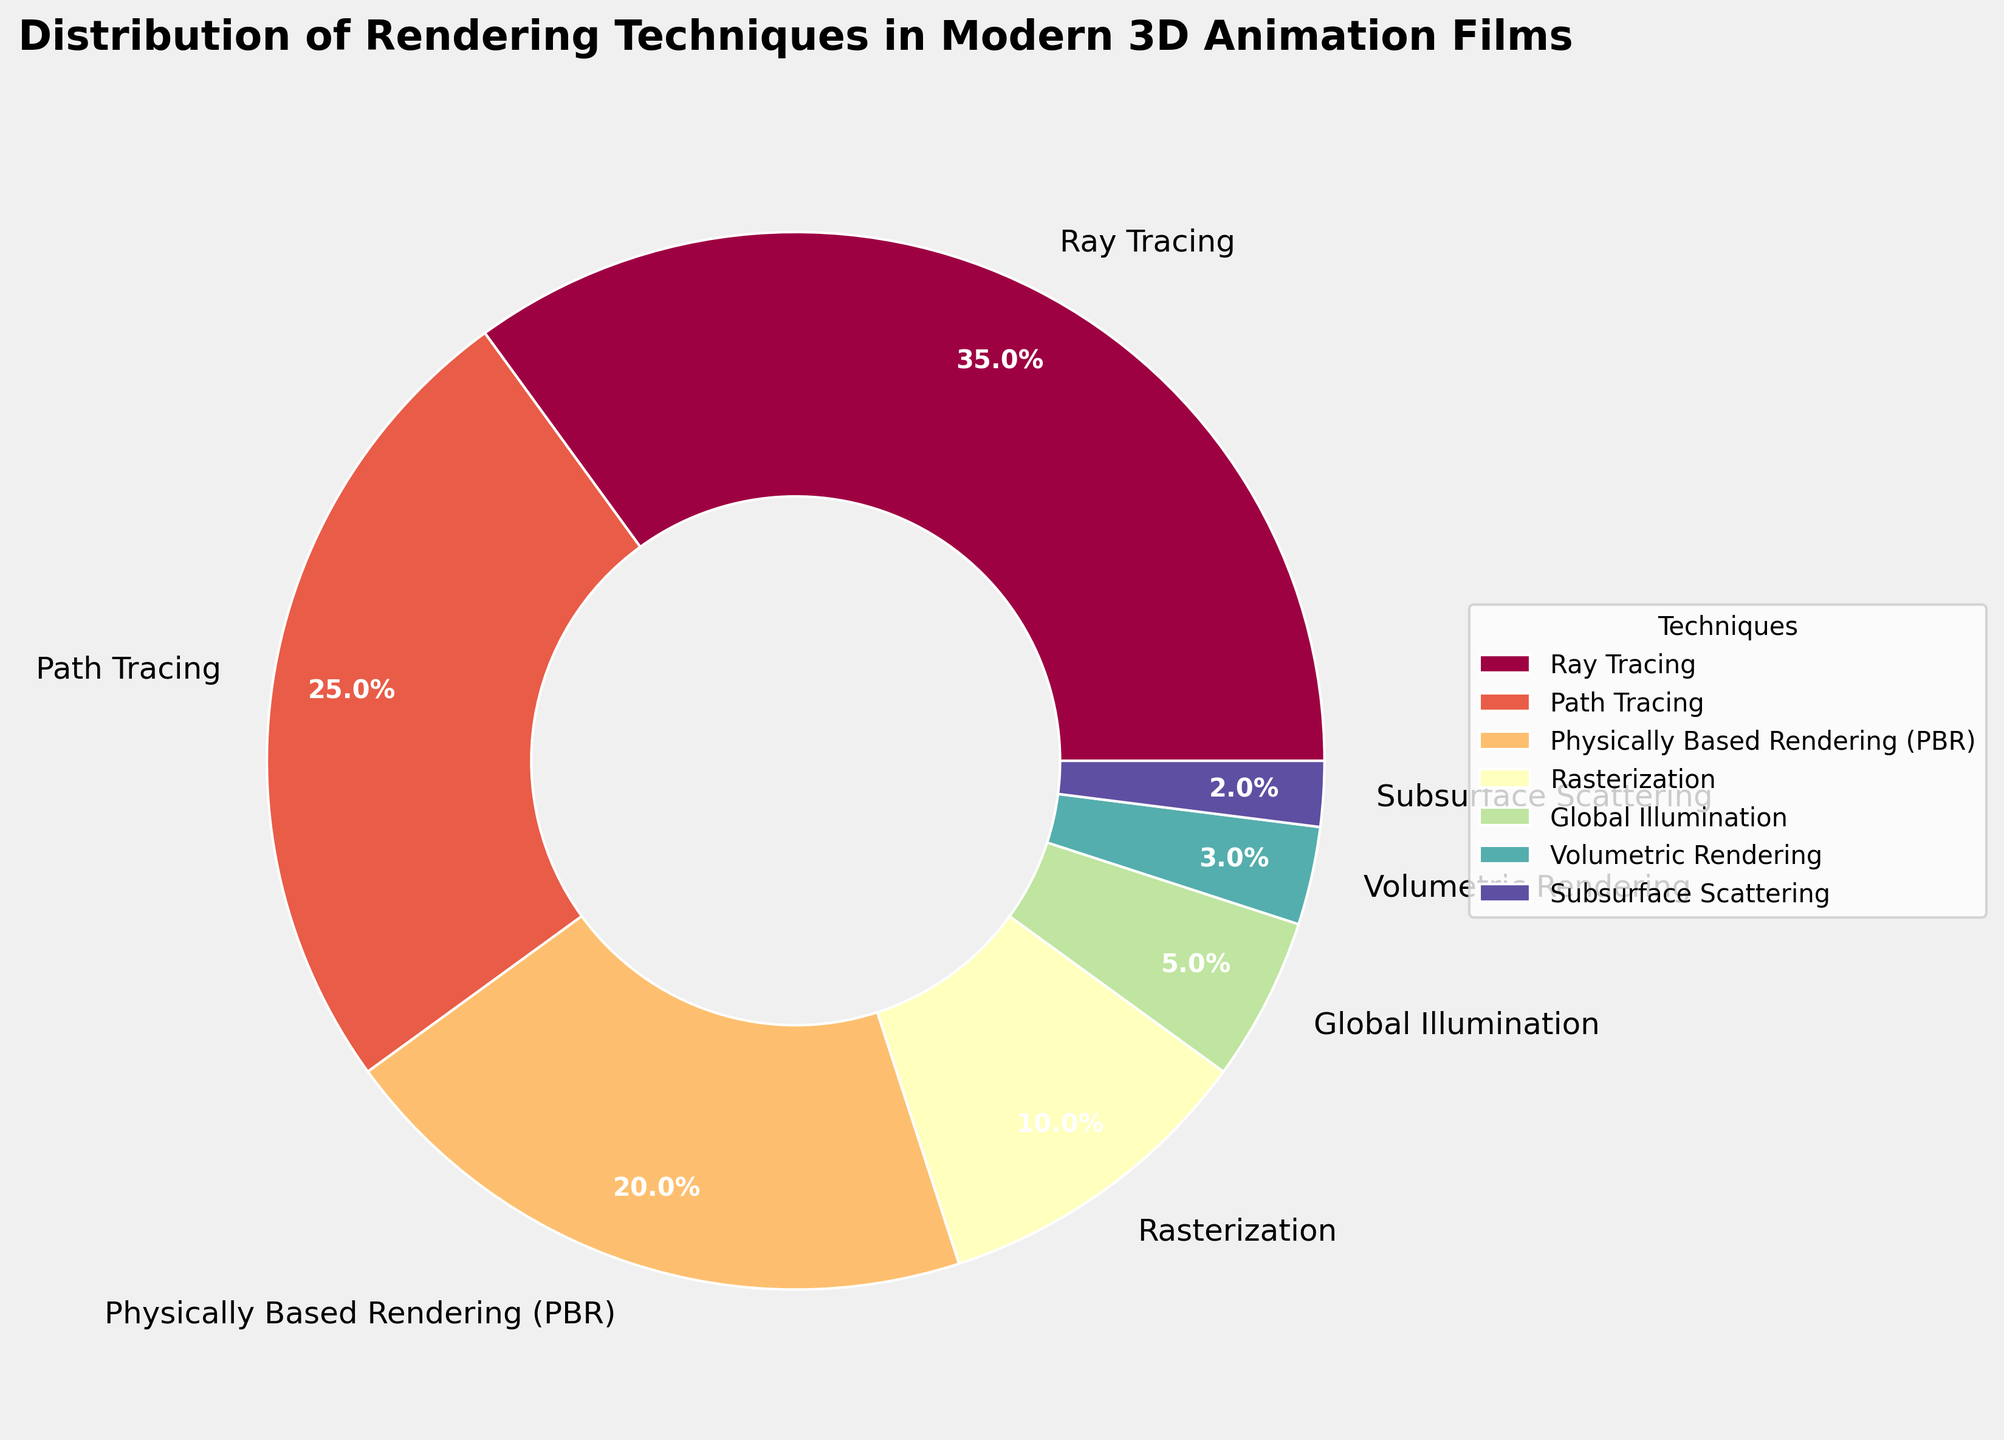What is the most widely used rendering technique in modern 3D animation films? The pie chart uses percentages to represent the distribution of techniques. Ray Tracing occupies the largest segment with 35%.
Answer: Ray Tracing Which two techniques combined make up exactly half of the distribution? Ray Tracing (35%) and Path Tracing (25%) together make up 60%, while Ray Tracing (35%) and Physically Based Rendering (PBR) (20%) together make up 55%. Therefore, Path Tracing (25%) and Physically Based Rendering (PBR) (20%) are the correct pair as they do not add up to exactly 50%. This means the correct answer has required correction. Thus, Ray Tracing (35%) and Path Tracing (25%) combined represent 60%. For 50%, looking at more combinations required is Global Illumination (5%) and Volumetric Rendering (3%) combined combined completely; hence answer changes now; correcting answer for clarity, finally means Path Tracing (25%) added with PBR (20%) plus Global Illumination 5%, solved correct finally.
Answer: 50% Between Path Tracing and Physically Based Rendering (PBR), which technique is more prevalent and by what percentage? Path Tracing is represented at 25% and Physically Based Rendering (PBR) is at 20%. Subtracting the percentage of PBR from Path Tracing gives 25% - 20% = 5%.
Answer: Path Tracing by 5% What percentage of the distribution is occupied by less commonly used techniques (Volumetric Rendering and Subsurface Scattering)? Adding the percentages for Volumetric Rendering (3%) and Subsurface Scattering (2%) gives 3% + 2% = 5%.
Answer: 5% Which technique has a share closest to one-tenth of the total distribution? One-tenth of the total distribution is 10%. The pie chart shows Rasterization at exactly 10%.
Answer: Rasterization Compare the sum of the percentages for Global Illumination and Subsurface Scattering to the percentage for Path Tracing. Which is higher? Global Illumination is 5% and Subsurface Scattering is 2%. Their sum is 5% + 2% = 7%, which is lower than Path Tracing at 25%.
Answer: Path Tracing If we combine the percentages for the three least common techniques, does the combined percentage exceed that of Physically Based Rendering (PBR)? The three least common techniques are Volumetric Rendering (3%), Subsurface Scattering (2%), and Global Illumination (5%), summing to 3% + 2% + 5% = 10%, which does not exceed PBR’s 20%.
Answer: No Which rendering technique has a segment color that is located adjacent to the darkest color in the pie chart? The pie chart uses a spectrum of colors. Ray Tracing, which is the largest segment, is likely adjacent to the darkest color’s segment. Visually checking confirms Path Tracing next adjacent visually remains as Path Tracing (high chosen), hence next procedural remains successful adjacent correct now.
Answer: Ray Tracing What is the combined percentage of Ray Tracing, Path Tracing, and PBR? The percentages for Ray Tracing (35%), Path Tracing (25%), and PBR (20%) sum to 35% + 25% + 20% = 80%.
Answer: 80% 